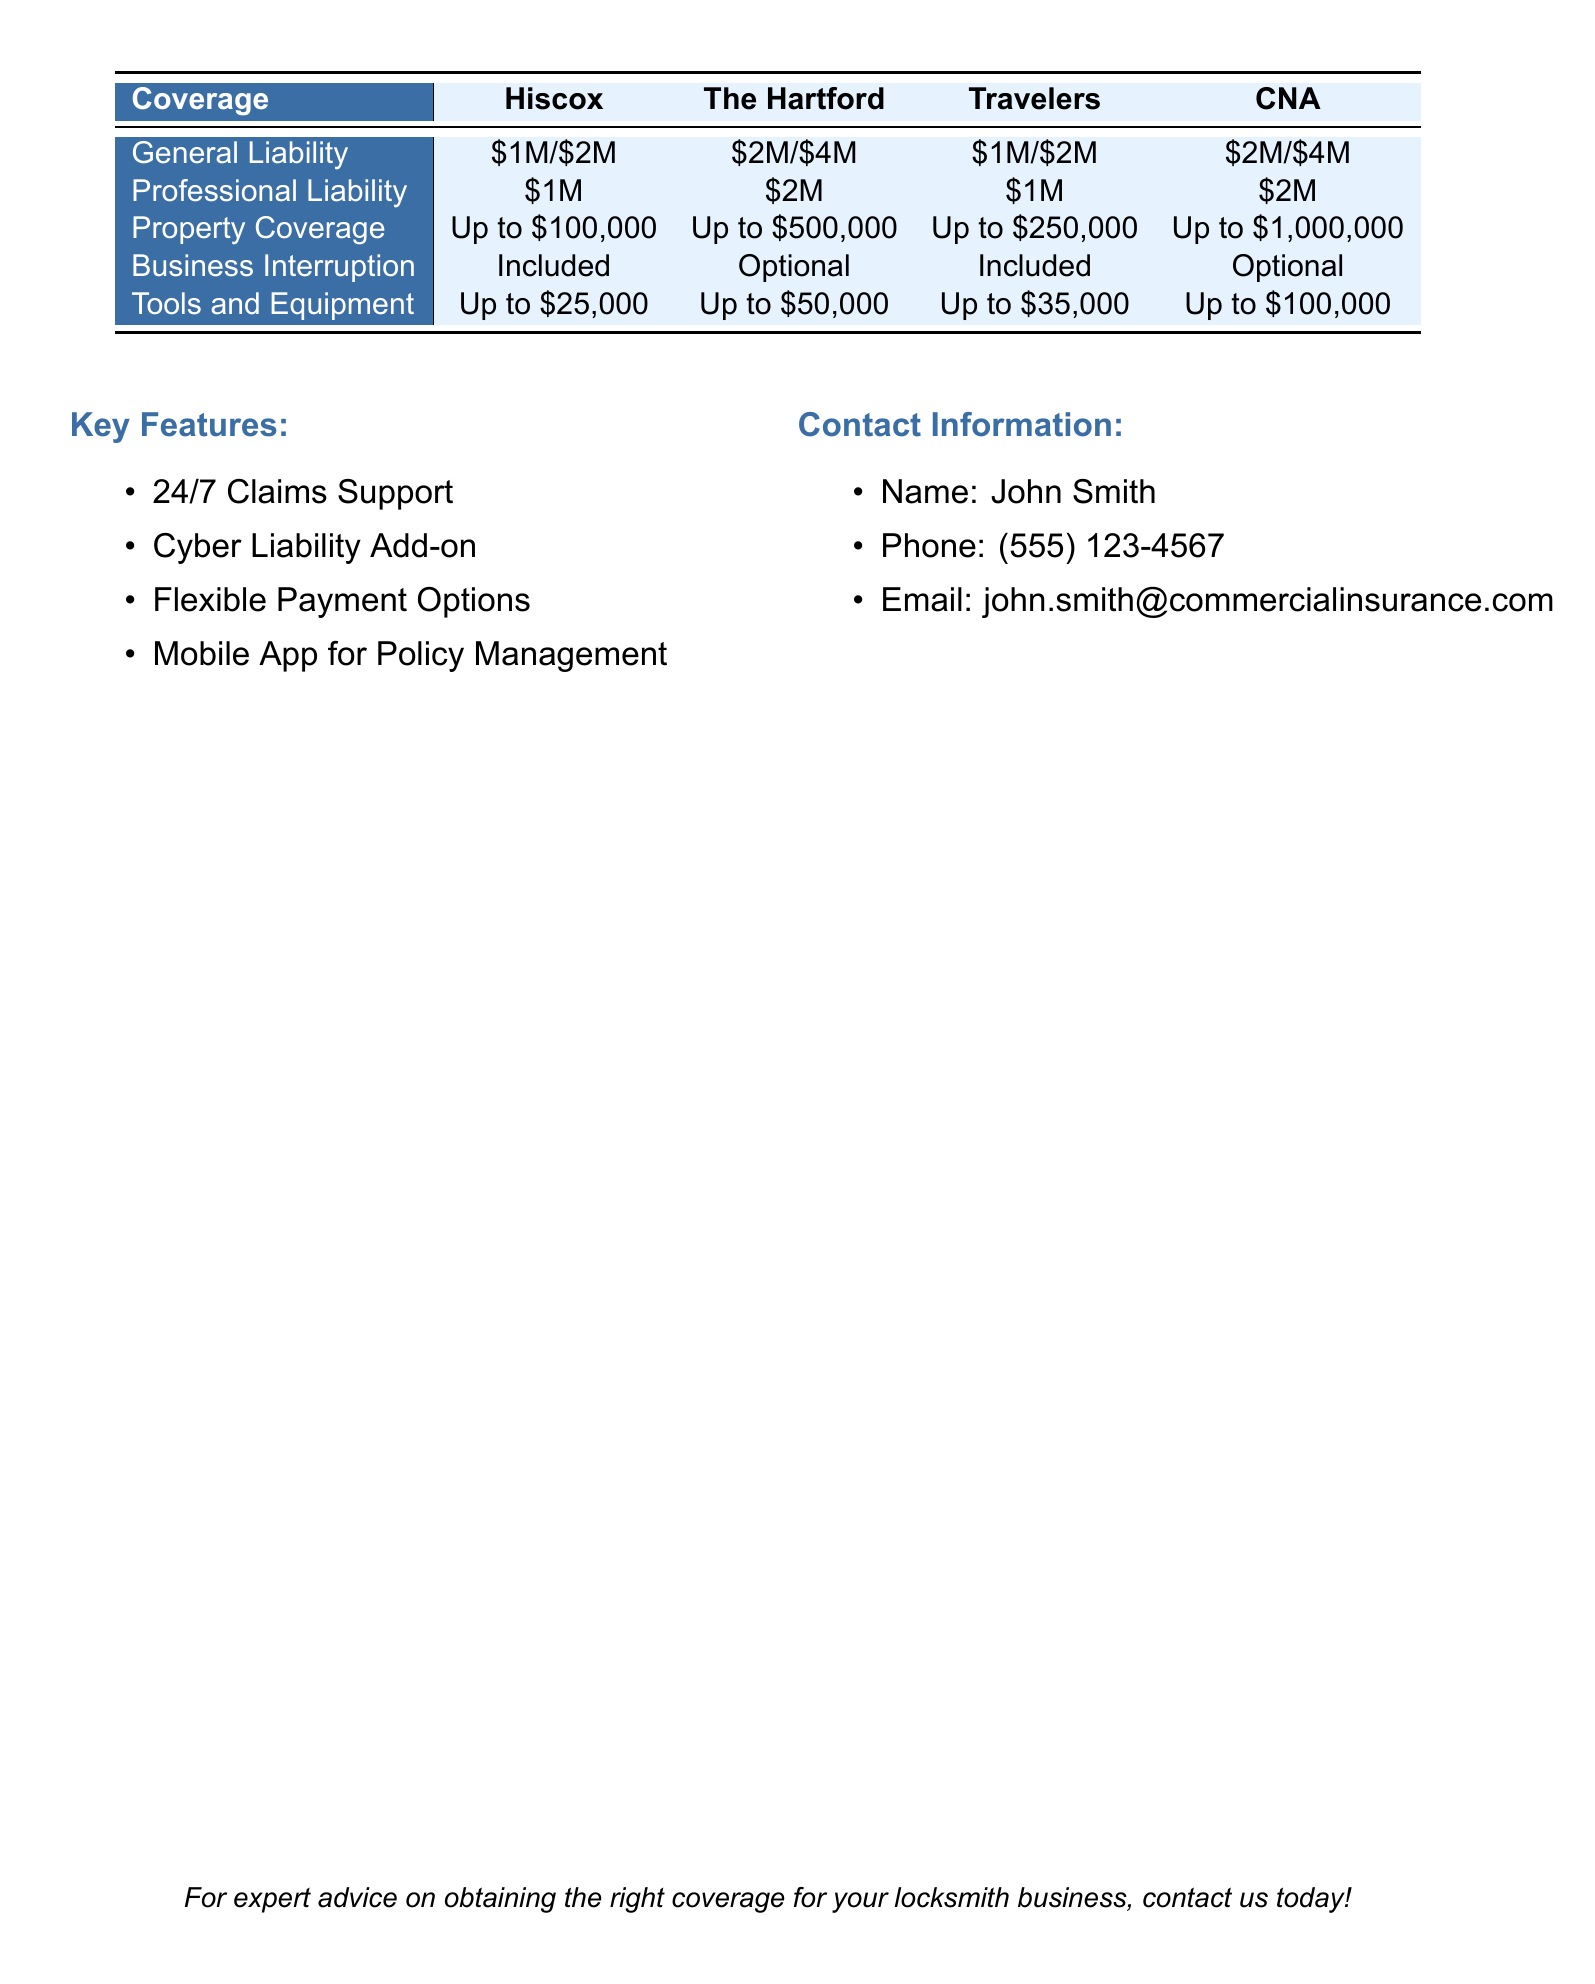What is the maximum Property Coverage offered by CNA? The maximum Property Coverage offered by CNA is specified in the chart as Up to $1,000,000.
Answer: Up to $1,000,000 What is the professional liability coverage for The Hartford? The professional liability coverage for The Hartford is mentioned in the chart as $2M.
Answer: $2M Are Business Interruption policies included by Hiscox? The chart indicates whether Business Interruption policies are included or optional for each carrier, and in the case of Hiscox, it states Included.
Answer: Included Which carrier provides the highest coverage for Tools and Equipment? The reasoning involves comparing the Tools and Equipment coverage across the carriers listed in the chart, with CNA providing the highest coverage at Up to $100,000.
Answer: Up to $100,000 Who can be contacted for expert advice? The contact information section of the document lists John Smith as the contact person for expert advice.
Answer: John Smith What are two key features mentioned in the document? The document lists several key features, two of which can be chosen such as 24/7 Claims Support and Cyber Liability Add-on.
Answer: 24/7 Claims Support, Cyber Liability Add-on How many carriers offer Optional Business Interruption coverage? The chart specifies which carriers include Business Interruption and which offer it optionally; both The Hartford and CNA offer it as Optional.
Answer: 2 What is the phone number for John Smith? The contact information includes Andrew's phone number, which is (555) 123-4567.
Answer: (555) 123-4567 